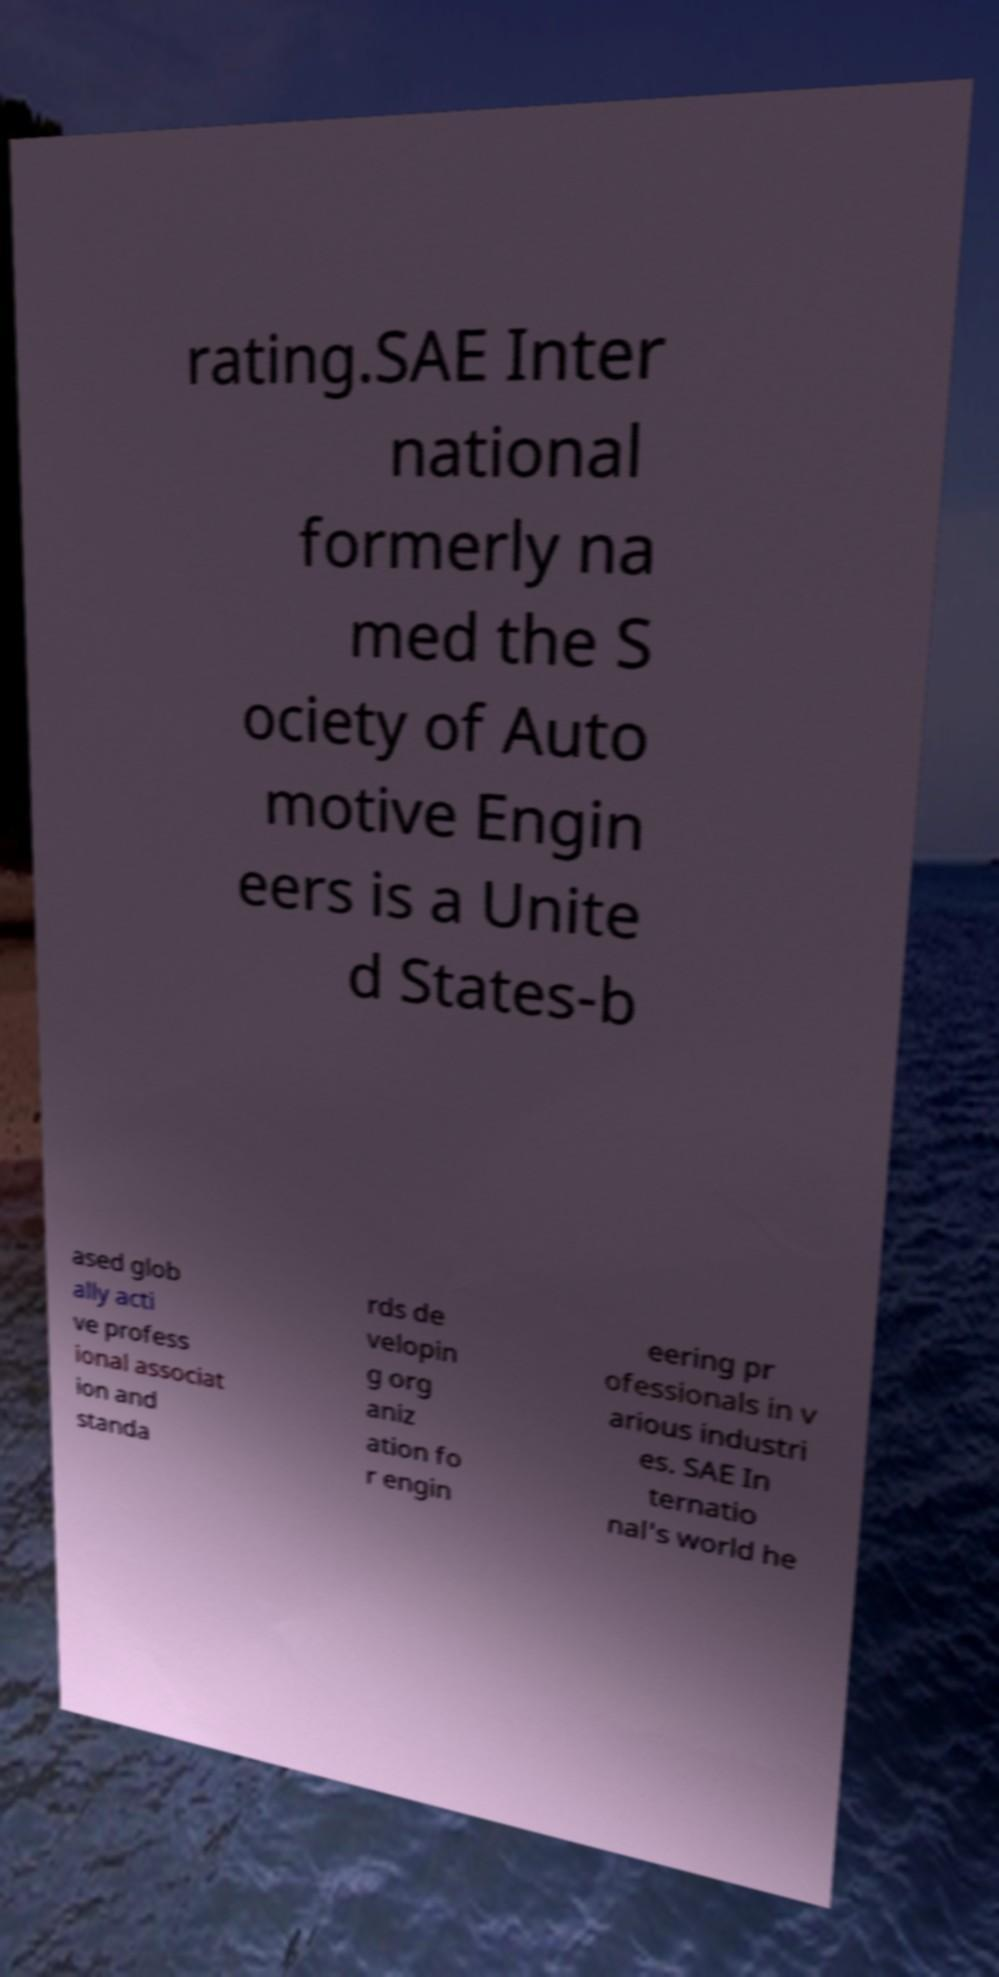Can you accurately transcribe the text from the provided image for me? rating.SAE Inter national formerly na med the S ociety of Auto motive Engin eers is a Unite d States-b ased glob ally acti ve profess ional associat ion and standa rds de velopin g org aniz ation fo r engin eering pr ofessionals in v arious industri es. SAE In ternatio nal's world he 